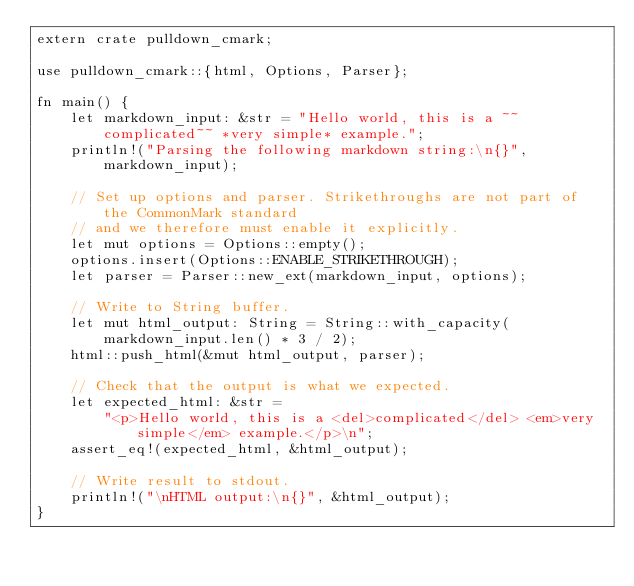<code> <loc_0><loc_0><loc_500><loc_500><_Rust_>extern crate pulldown_cmark;

use pulldown_cmark::{html, Options, Parser};

fn main() {
    let markdown_input: &str = "Hello world, this is a ~~complicated~~ *very simple* example.";
    println!("Parsing the following markdown string:\n{}", markdown_input);

    // Set up options and parser. Strikethroughs are not part of the CommonMark standard
    // and we therefore must enable it explicitly.
    let mut options = Options::empty();
    options.insert(Options::ENABLE_STRIKETHROUGH);
    let parser = Parser::new_ext(markdown_input, options);

    // Write to String buffer.
    let mut html_output: String = String::with_capacity(markdown_input.len() * 3 / 2);
    html::push_html(&mut html_output, parser);

    // Check that the output is what we expected.
    let expected_html: &str =
        "<p>Hello world, this is a <del>complicated</del> <em>very simple</em> example.</p>\n";
    assert_eq!(expected_html, &html_output);

    // Write result to stdout.
    println!("\nHTML output:\n{}", &html_output);
}
</code> 